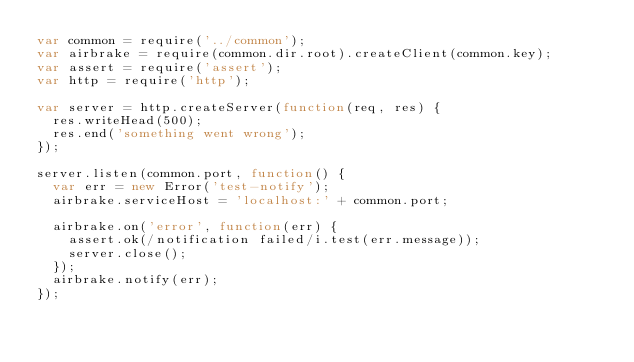Convert code to text. <code><loc_0><loc_0><loc_500><loc_500><_JavaScript_>var common = require('../common');
var airbrake = require(common.dir.root).createClient(common.key);
var assert = require('assert');
var http = require('http');

var server = http.createServer(function(req, res) {
  res.writeHead(500);
  res.end('something went wrong');
});

server.listen(common.port, function() {
  var err = new Error('test-notify');
  airbrake.serviceHost = 'localhost:' + common.port;

  airbrake.on('error', function(err) {
    assert.ok(/notification failed/i.test(err.message));
    server.close();
  });
  airbrake.notify(err);
});
</code> 